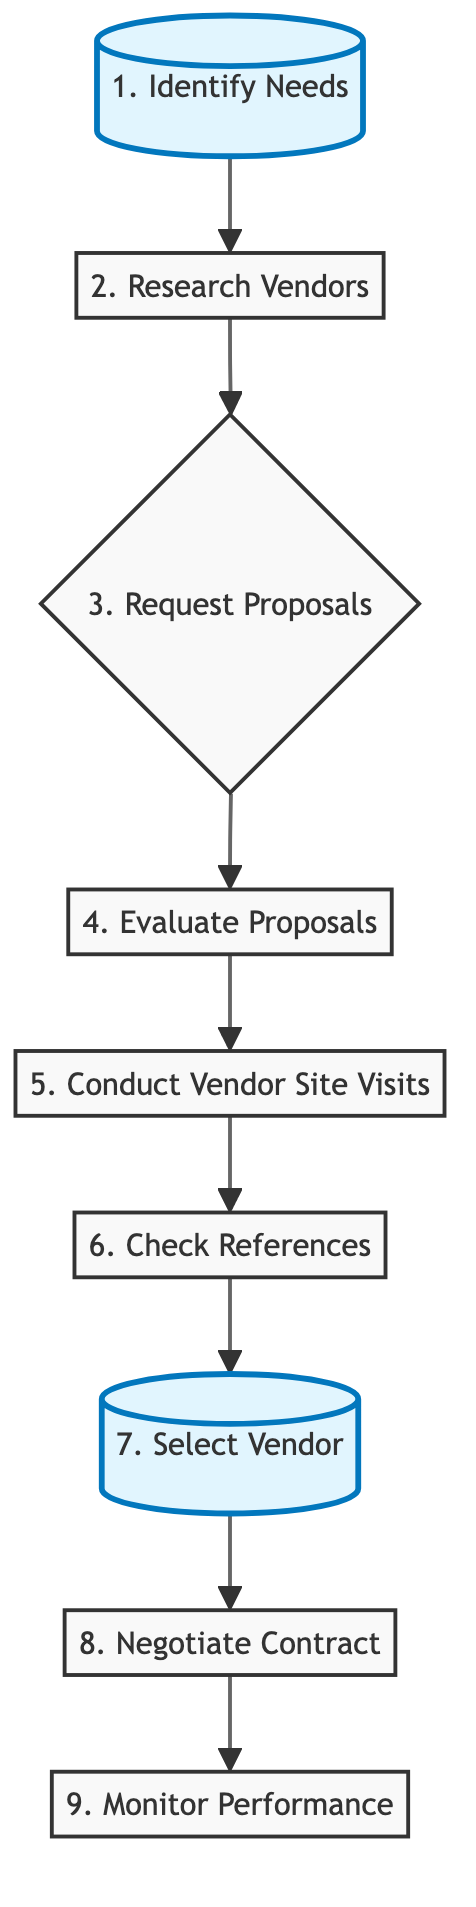What is the first step in the vendor selection process? The diagram indicates that the first step is labeled "1. Identify Needs," which determines the specific supplies needed for the school.
Answer: Identify Needs How many nodes are there in the flow chart? By counting all the unique elements in the diagram, we can see there are a total of 9 nodes representing the entire process from identifying needs to monitoring performance.
Answer: 9 What is the last step after selecting the vendor? The diagram shows that after the "7. Select Vendor," the subsequent step is "8. Negotiate Contract."
Answer: Negotiate Contract Which step follows conducting vendor site visits? Per the flowchart, after "5. Conduct Vendor Site Visits," the next action is "6. Check References."
Answer: Check References Which step involves assessing vendor capabilities? The step labeled "5. Conduct Vendor Site Visits" is specifically dedicated to assessing the vendors' capabilities and reliability through direct visits.
Answer: Conduct Vendor Site Visits What action is taken after evaluating proposals? According to the flowchart, once the proposals are evaluated in step "4. Evaluate Proposals," the next step to execute is "5. Conduct Vendor Site Visits."
Answer: Conduct Vendor Site Visits How does checking references connect to selecting a vendor? The diagram depicts a direct flow where "6. Check References" leads to "7. Select Vendor," implying that references influence the decision of which vendor to select.
Answer: Select Vendor How many steps are there before negotiating the contract? Referring to the flowchart, there are 7 steps preceding "8. Negotiate Contract," starting from "1. Identify Needs" and moving through to "7. Select Vendor."
Answer: 7 What purpose does the step "Monitor Performance" serve? The step "9. Monitor Performance" is intended for evaluating the vendor's effectiveness upon delivery of supplies, ensuring quality and reliability.
Answer: Evaluate vendor's performance 